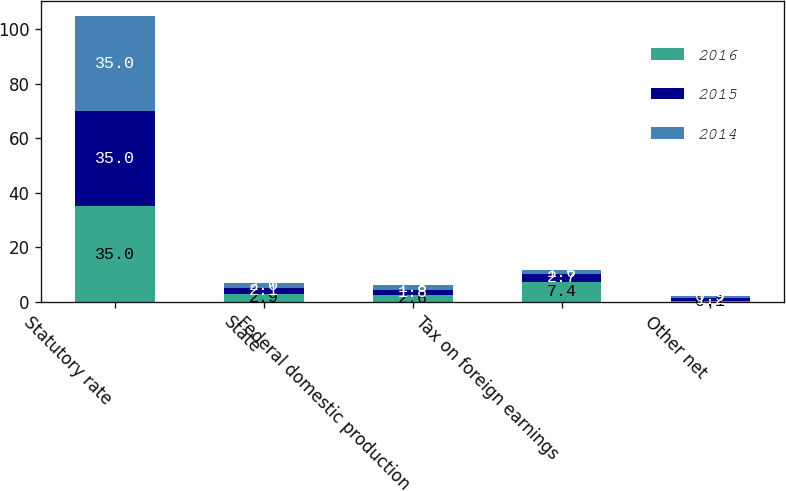<chart> <loc_0><loc_0><loc_500><loc_500><stacked_bar_chart><ecel><fcel>Statutory rate<fcel>State<fcel>Federal domestic production<fcel>Tax on foreign earnings<fcel>Other net<nl><fcel>2016<fcel>35<fcel>2.9<fcel>2.6<fcel>7.4<fcel>0.1<nl><fcel>2015<fcel>35<fcel>2.1<fcel>1.8<fcel>2.7<fcel>1.2<nl><fcel>2014<fcel>35<fcel>2<fcel>1.8<fcel>1.6<fcel>0.9<nl></chart> 